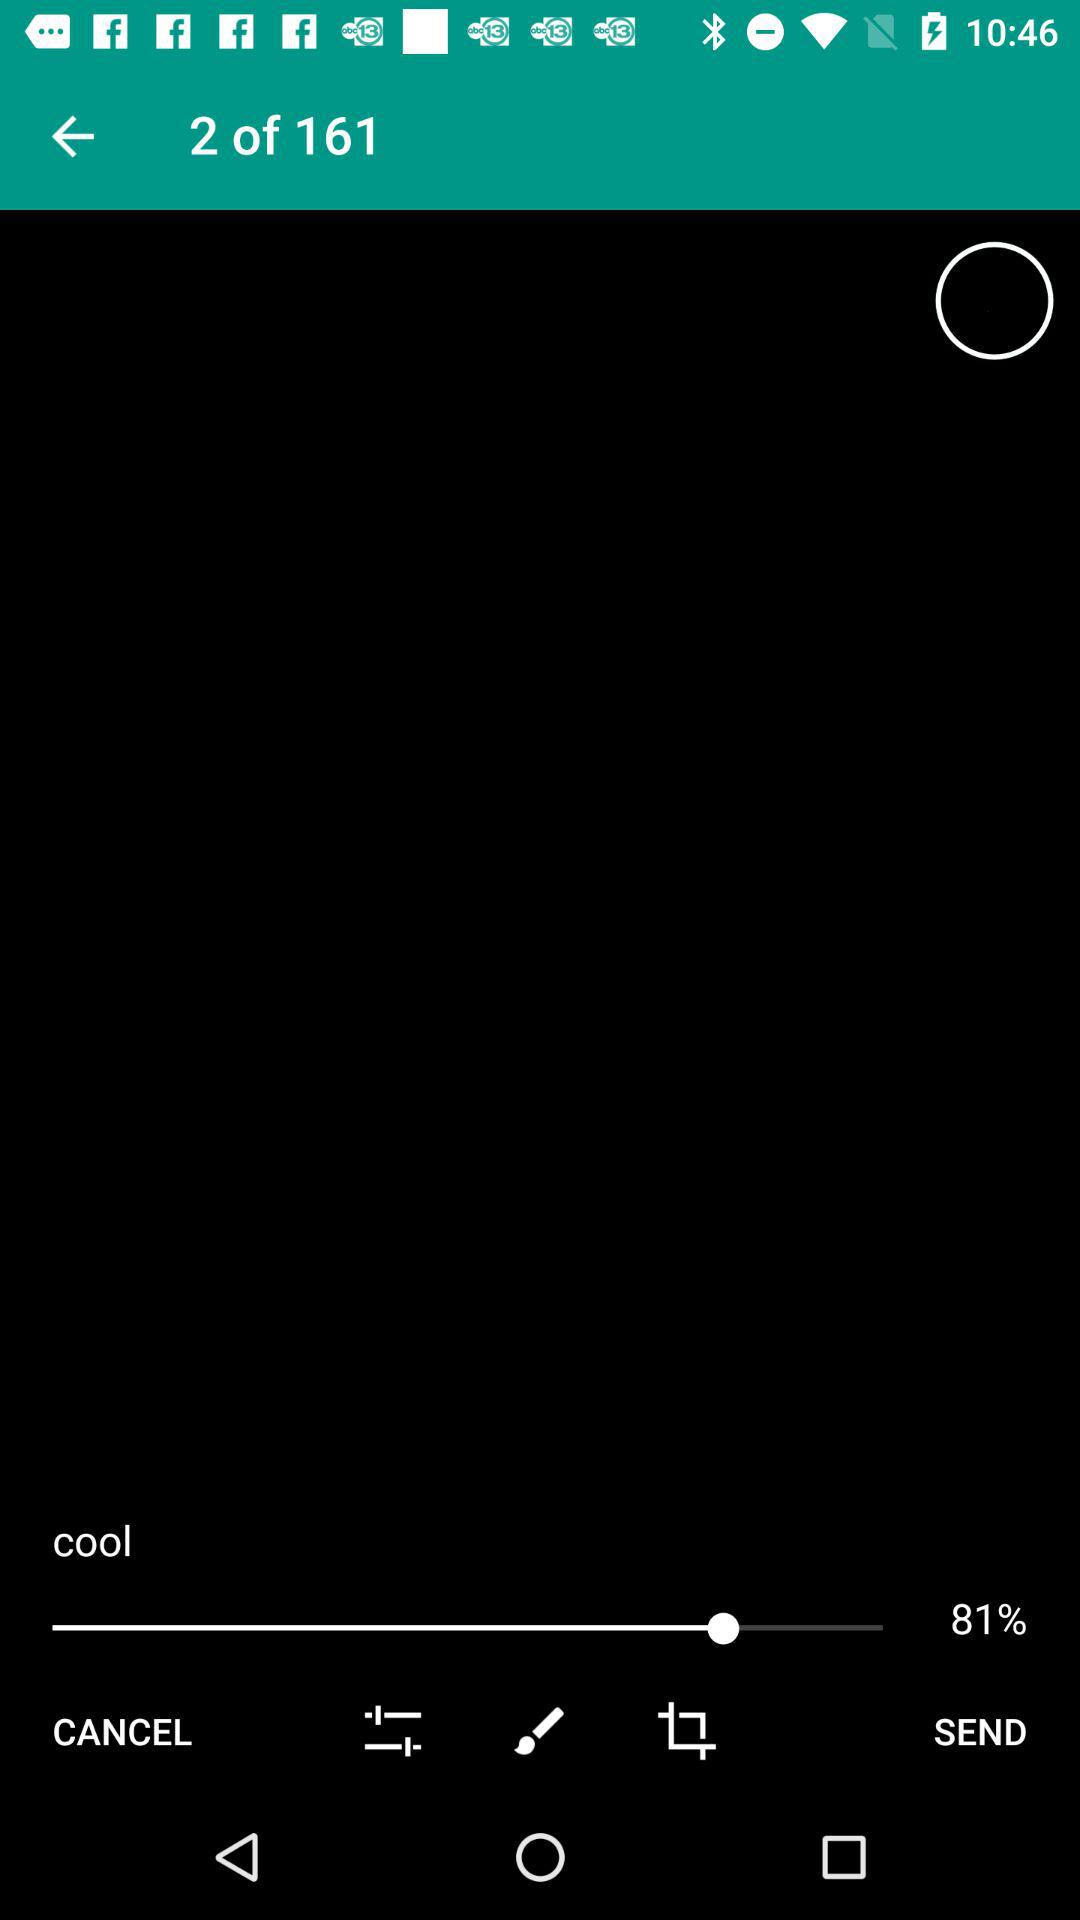Which page am I on? You are on page number 2. 